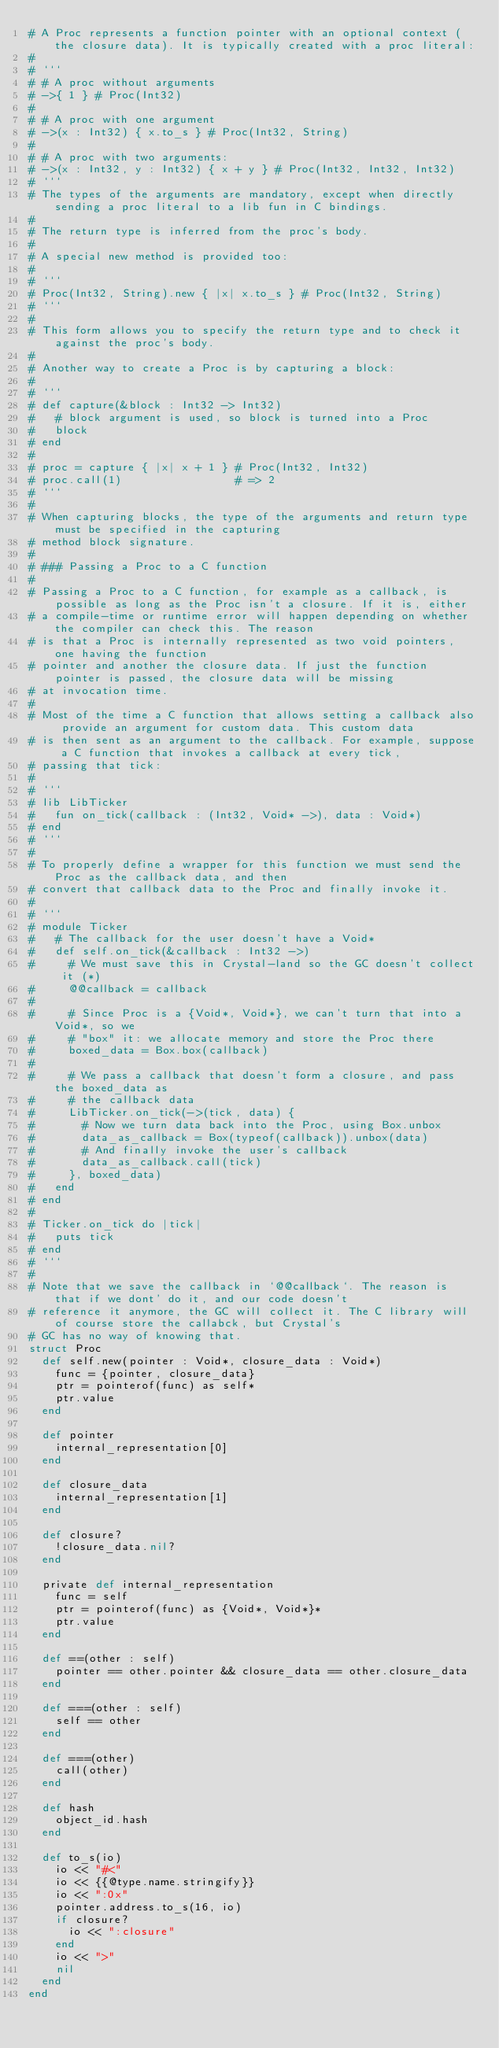<code> <loc_0><loc_0><loc_500><loc_500><_Crystal_># A Proc represents a function pointer with an optional context (the closure data). It is typically created with a proc literal:
#
# ```
# # A proc without arguments
# ->{ 1 } # Proc(Int32)
#
# # A proc with one argument
# ->(x : Int32) { x.to_s } # Proc(Int32, String)
#
# # A proc with two arguments:
# ->(x : Int32, y : Int32) { x + y } # Proc(Int32, Int32, Int32)
# ```
# The types of the arguments are mandatory, except when directly sending a proc literal to a lib fun in C bindings.
#
# The return type is inferred from the proc's body.
#
# A special new method is provided too:
#
# ```
# Proc(Int32, String).new { |x| x.to_s } # Proc(Int32, String)
# ```
#
# This form allows you to specify the return type and to check it against the proc's body.
#
# Another way to create a Proc is by capturing a block:
#
# ```
# def capture(&block : Int32 -> Int32)
#   # block argument is used, so block is turned into a Proc
#   block
# end
#
# proc = capture { |x| x + 1 } # Proc(Int32, Int32)
# proc.call(1)                 # => 2
# ```
#
# When capturing blocks, the type of the arguments and return type must be specified in the capturing
# method block signature.
#
# ### Passing a Proc to a C function
#
# Passing a Proc to a C function, for example as a callback, is possible as long as the Proc isn't a closure. If it is, either
# a compile-time or runtime error will happen depending on whether the compiler can check this. The reason
# is that a Proc is internally represented as two void pointers, one having the function
# pointer and another the closure data. If just the function pointer is passed, the closure data will be missing
# at invocation time.
#
# Most of the time a C function that allows setting a callback also provide an argument for custom data. This custom data
# is then sent as an argument to the callback. For example, suppose a C function that invokes a callback at every tick,
# passing that tick:
#
# ```
# lib LibTicker
#   fun on_tick(callback : (Int32, Void* ->), data : Void*)
# end
# ```
#
# To properly define a wrapper for this function we must send the Proc as the callback data, and then
# convert that callback data to the Proc and finally invoke it.
#
# ```
# module Ticker
#   # The callback for the user doesn't have a Void*
#   def self.on_tick(&callback : Int32 ->)
#     # We must save this in Crystal-land so the GC doesn't collect it (*)
#     @@callback = callback
#
#     # Since Proc is a {Void*, Void*}, we can't turn that into a Void*, so we
#     # "box" it: we allocate memory and store the Proc there
#     boxed_data = Box.box(callback)
#
#     # We pass a callback that doesn't form a closure, and pass the boxed_data as
#     # the callback data
#     LibTicker.on_tick(->(tick, data) {
#       # Now we turn data back into the Proc, using Box.unbox
#       data_as_callback = Box(typeof(callback)).unbox(data)
#       # And finally invoke the user's callback
#       data_as_callback.call(tick)
#     }, boxed_data)
#   end
# end
#
# Ticker.on_tick do |tick|
#   puts tick
# end
# ```
#
# Note that we save the callback in `@@callback`. The reason is that if we dont' do it, and our code doesn't
# reference it anymore, the GC will collect it. The C library will of course store the callabck, but Crystal's
# GC has no way of knowing that.
struct Proc
  def self.new(pointer : Void*, closure_data : Void*)
    func = {pointer, closure_data}
    ptr = pointerof(func) as self*
    ptr.value
  end

  def pointer
    internal_representation[0]
  end

  def closure_data
    internal_representation[1]
  end

  def closure?
    !closure_data.nil?
  end

  private def internal_representation
    func = self
    ptr = pointerof(func) as {Void*, Void*}*
    ptr.value
  end

  def ==(other : self)
    pointer == other.pointer && closure_data == other.closure_data
  end

  def ===(other : self)
    self == other
  end

  def ===(other)
    call(other)
  end

  def hash
    object_id.hash
  end

  def to_s(io)
    io << "#<"
    io << {{@type.name.stringify}}
    io << ":0x"
    pointer.address.to_s(16, io)
    if closure?
      io << ":closure"
    end
    io << ">"
    nil
  end
end
</code> 